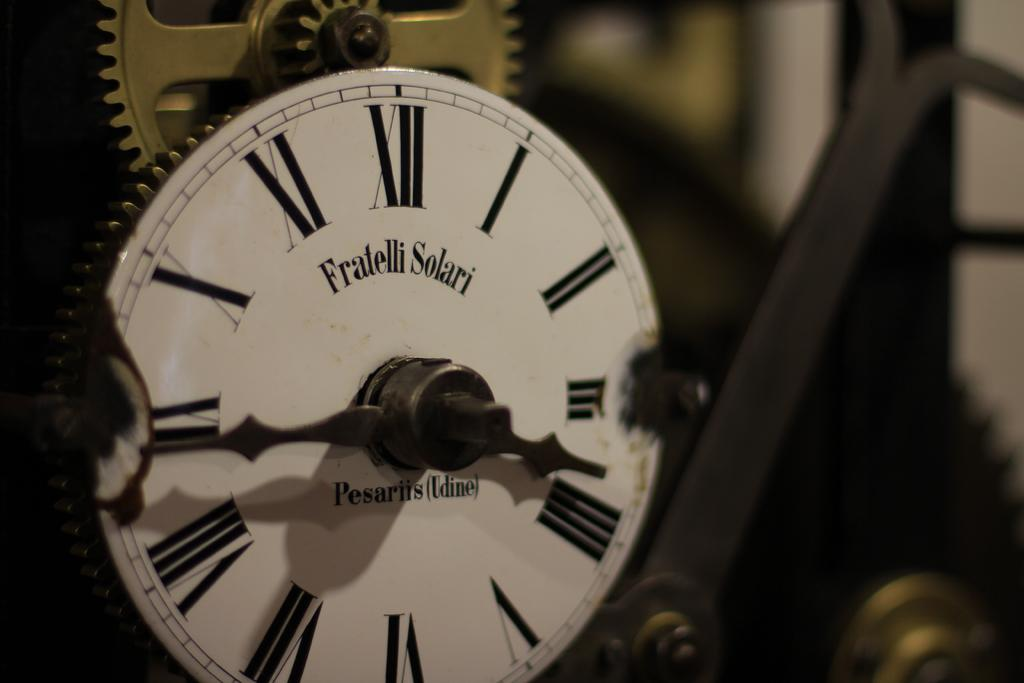What is the main feature of the image? The image contains a clock dial. What type of numerals are used on the clock dial? The clock dial has roman numerals. Is there any text on the clock dial? Yes, there is text on the clock dial. What can be found on the backside of the clock? The backside of the clock contains a gear. Can you see a hand holding a pan with a fish in the image? No, there is no hand, pan, or fish present in the image; it only contains a clock dial with roman numerals, text, and a gear on the backside. 